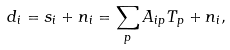<formula> <loc_0><loc_0><loc_500><loc_500>d _ { i } = s _ { i } + n _ { i } = \sum _ { p } A _ { i p } T _ { p } + n _ { i } ,</formula> 